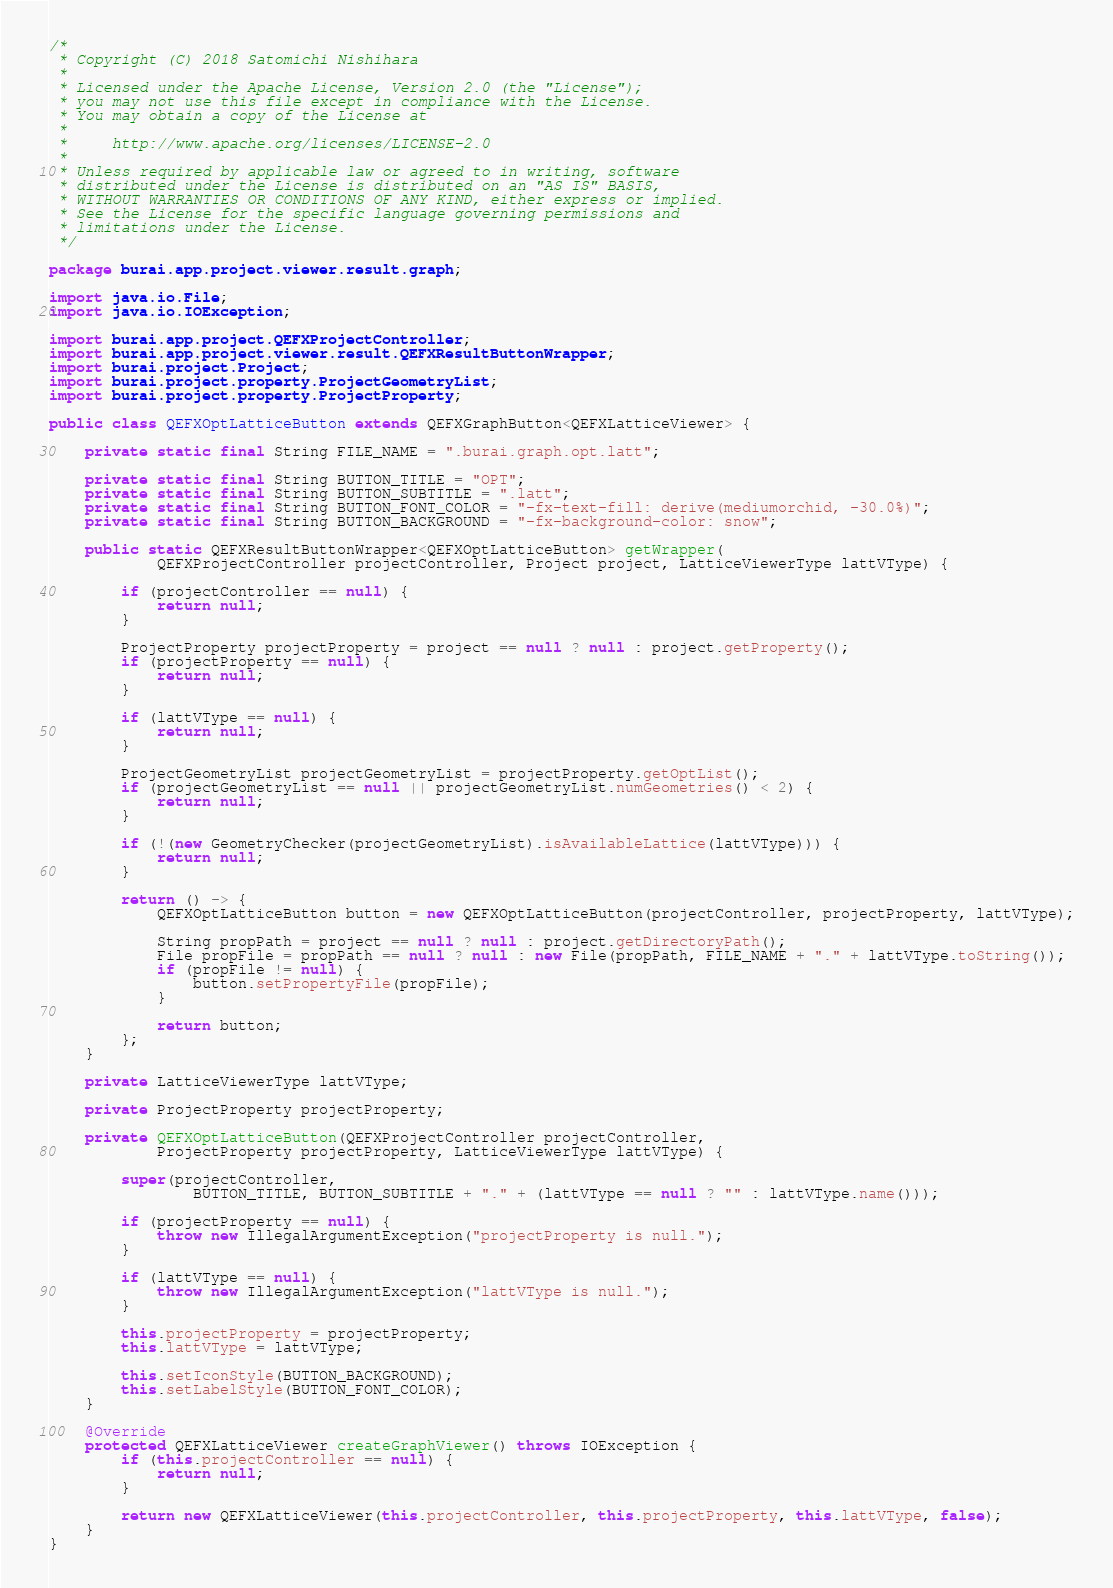Convert code to text. <code><loc_0><loc_0><loc_500><loc_500><_Java_>/*
 * Copyright (C) 2018 Satomichi Nishihara
 *
 * Licensed under the Apache License, Version 2.0 (the "License");
 * you may not use this file except in compliance with the License.
 * You may obtain a copy of the License at
 *
 *     http://www.apache.org/licenses/LICENSE-2.0
 *
 * Unless required by applicable law or agreed to in writing, software
 * distributed under the License is distributed on an "AS IS" BASIS,
 * WITHOUT WARRANTIES OR CONDITIONS OF ANY KIND, either express or implied.
 * See the License for the specific language governing permissions and
 * limitations under the License.
 */

package burai.app.project.viewer.result.graph;

import java.io.File;
import java.io.IOException;

import burai.app.project.QEFXProjectController;
import burai.app.project.viewer.result.QEFXResultButtonWrapper;
import burai.project.Project;
import burai.project.property.ProjectGeometryList;
import burai.project.property.ProjectProperty;

public class QEFXOptLatticeButton extends QEFXGraphButton<QEFXLatticeViewer> {

    private static final String FILE_NAME = ".burai.graph.opt.latt";

    private static final String BUTTON_TITLE = "OPT";
    private static final String BUTTON_SUBTITLE = ".latt";
    private static final String BUTTON_FONT_COLOR = "-fx-text-fill: derive(mediumorchid, -30.0%)";
    private static final String BUTTON_BACKGROUND = "-fx-background-color: snow";

    public static QEFXResultButtonWrapper<QEFXOptLatticeButton> getWrapper(
            QEFXProjectController projectController, Project project, LatticeViewerType lattVType) {

        if (projectController == null) {
            return null;
        }

        ProjectProperty projectProperty = project == null ? null : project.getProperty();
        if (projectProperty == null) {
            return null;
        }

        if (lattVType == null) {
            return null;
        }

        ProjectGeometryList projectGeometryList = projectProperty.getOptList();
        if (projectGeometryList == null || projectGeometryList.numGeometries() < 2) {
            return null;
        }

        if (!(new GeometryChecker(projectGeometryList).isAvailableLattice(lattVType))) {
            return null;
        }

        return () -> {
            QEFXOptLatticeButton button = new QEFXOptLatticeButton(projectController, projectProperty, lattVType);

            String propPath = project == null ? null : project.getDirectoryPath();
            File propFile = propPath == null ? null : new File(propPath, FILE_NAME + "." + lattVType.toString());
            if (propFile != null) {
                button.setPropertyFile(propFile);
            }

            return button;
        };
    }

    private LatticeViewerType lattVType;

    private ProjectProperty projectProperty;

    private QEFXOptLatticeButton(QEFXProjectController projectController,
            ProjectProperty projectProperty, LatticeViewerType lattVType) {

        super(projectController,
                BUTTON_TITLE, BUTTON_SUBTITLE + "." + (lattVType == null ? "" : lattVType.name()));

        if (projectProperty == null) {
            throw new IllegalArgumentException("projectProperty is null.");
        }

        if (lattVType == null) {
            throw new IllegalArgumentException("lattVType is null.");
        }

        this.projectProperty = projectProperty;
        this.lattVType = lattVType;

        this.setIconStyle(BUTTON_BACKGROUND);
        this.setLabelStyle(BUTTON_FONT_COLOR);
    }

    @Override
    protected QEFXLatticeViewer createGraphViewer() throws IOException {
        if (this.projectController == null) {
            return null;
        }

        return new QEFXLatticeViewer(this.projectController, this.projectProperty, this.lattVType, false);
    }
}
</code> 